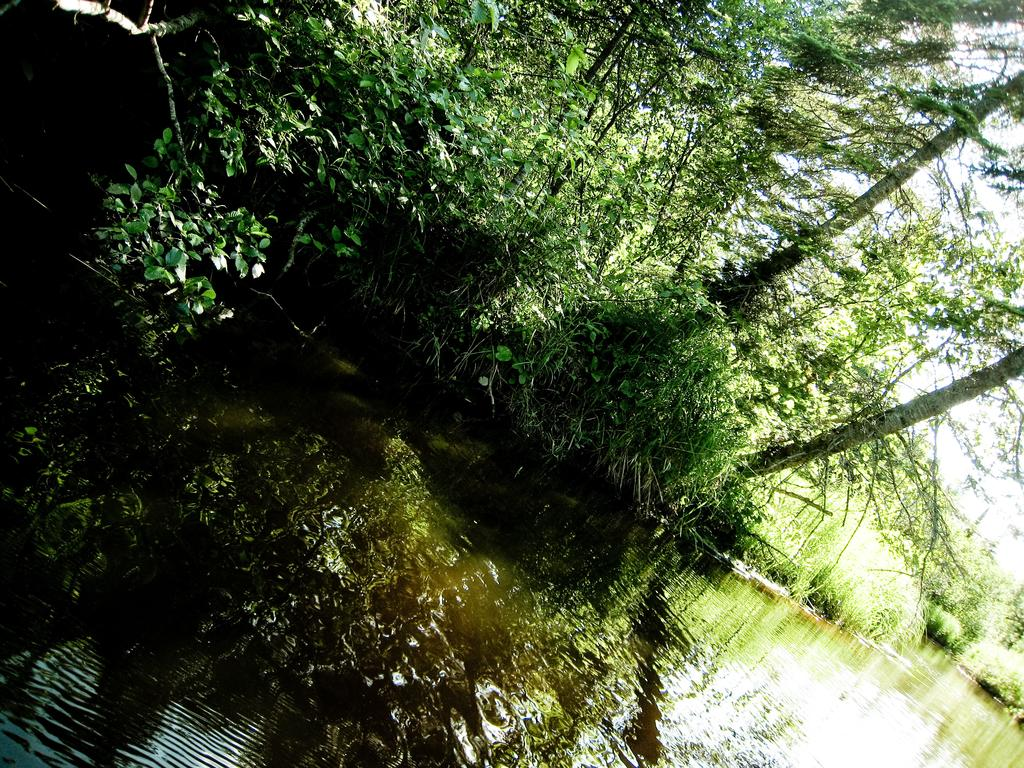What is visible in the front of the image? There is water in the front of the image. What can be seen in the background of the image? There are trees in the background of the image. What type of motion is demonstrated by the skate in the image? There is no skate present in the image. What scientific principles can be observed in the image? The image does not depict any scientific principles; it features water and trees. 